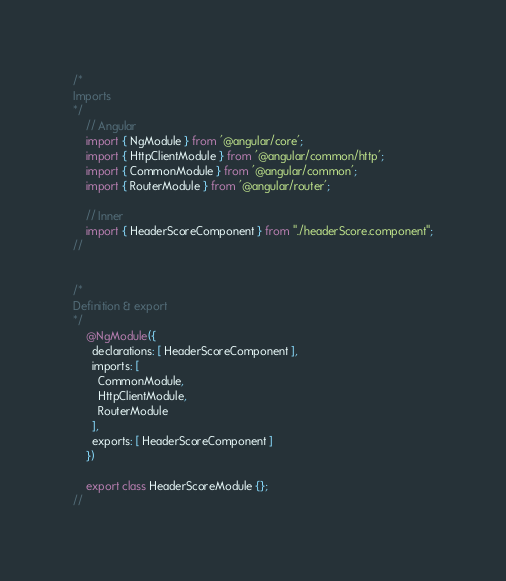<code> <loc_0><loc_0><loc_500><loc_500><_TypeScript_>/*
Imports
*/
    // Angular
    import { NgModule } from '@angular/core';
    import { HttpClientModule } from '@angular/common/http';
    import { CommonModule } from '@angular/common';
    import { RouterModule } from '@angular/router';

    // Inner
    import { HeaderScoreComponent } from "./headerScore.component";
//


/*
Definition & export
*/
    @NgModule({
      declarations: [ HeaderScoreComponent ],
      imports: [
        CommonModule,
        HttpClientModule,
        RouterModule
      ],
      exports: [ HeaderScoreComponent ]
    })

    export class HeaderScoreModule {};
//
</code> 